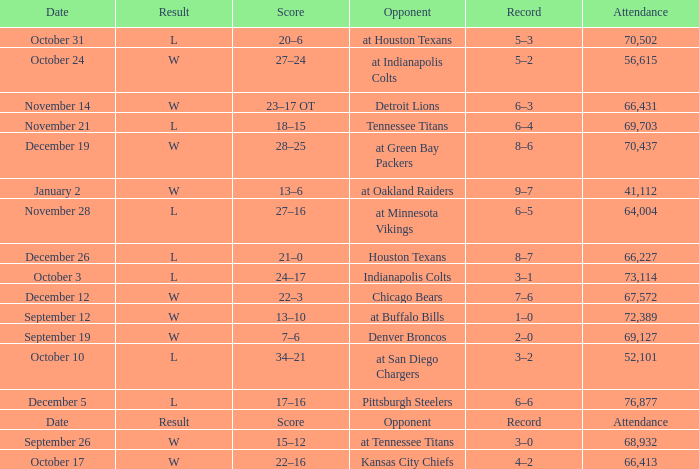What score has October 31 as the date? 20–6. 